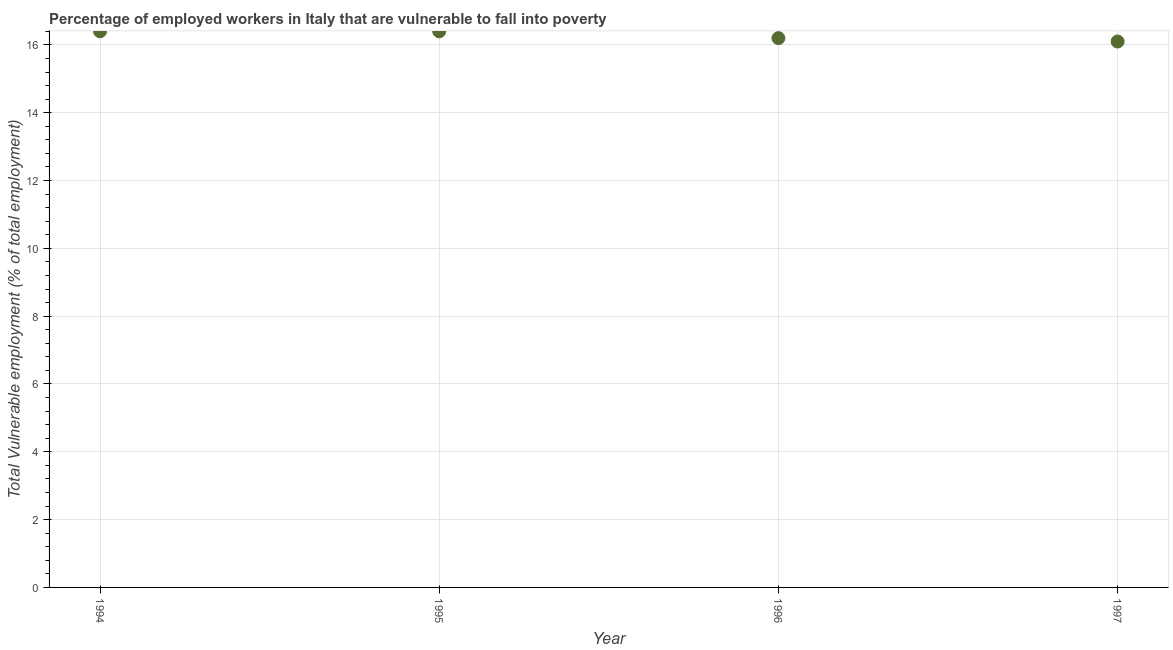What is the total vulnerable employment in 1995?
Your answer should be compact. 16.4. Across all years, what is the maximum total vulnerable employment?
Provide a succinct answer. 16.4. Across all years, what is the minimum total vulnerable employment?
Provide a succinct answer. 16.1. In which year was the total vulnerable employment maximum?
Provide a succinct answer. 1994. In which year was the total vulnerable employment minimum?
Offer a very short reply. 1997. What is the sum of the total vulnerable employment?
Keep it short and to the point. 65.1. What is the difference between the total vulnerable employment in 1994 and 1996?
Keep it short and to the point. 0.2. What is the average total vulnerable employment per year?
Your response must be concise. 16.28. What is the median total vulnerable employment?
Ensure brevity in your answer.  16.3. Do a majority of the years between 1994 and 1995 (inclusive) have total vulnerable employment greater than 14 %?
Your answer should be compact. Yes. What is the ratio of the total vulnerable employment in 1994 to that in 1996?
Your answer should be very brief. 1.01. Is the difference between the total vulnerable employment in 1995 and 1996 greater than the difference between any two years?
Provide a succinct answer. No. What is the difference between the highest and the second highest total vulnerable employment?
Offer a very short reply. 0. What is the difference between the highest and the lowest total vulnerable employment?
Your answer should be compact. 0.3. In how many years, is the total vulnerable employment greater than the average total vulnerable employment taken over all years?
Keep it short and to the point. 2. Does the total vulnerable employment monotonically increase over the years?
Your response must be concise. No. How many years are there in the graph?
Provide a succinct answer. 4. Are the values on the major ticks of Y-axis written in scientific E-notation?
Give a very brief answer. No. Does the graph contain grids?
Offer a terse response. Yes. What is the title of the graph?
Provide a succinct answer. Percentage of employed workers in Italy that are vulnerable to fall into poverty. What is the label or title of the X-axis?
Provide a succinct answer. Year. What is the label or title of the Y-axis?
Make the answer very short. Total Vulnerable employment (% of total employment). What is the Total Vulnerable employment (% of total employment) in 1994?
Your answer should be very brief. 16.4. What is the Total Vulnerable employment (% of total employment) in 1995?
Your answer should be compact. 16.4. What is the Total Vulnerable employment (% of total employment) in 1996?
Your response must be concise. 16.2. What is the Total Vulnerable employment (% of total employment) in 1997?
Your answer should be compact. 16.1. What is the difference between the Total Vulnerable employment (% of total employment) in 1994 and 1995?
Give a very brief answer. 0. What is the difference between the Total Vulnerable employment (% of total employment) in 1995 and 1997?
Your answer should be compact. 0.3. What is the difference between the Total Vulnerable employment (% of total employment) in 1996 and 1997?
Provide a short and direct response. 0.1. What is the ratio of the Total Vulnerable employment (% of total employment) in 1994 to that in 1997?
Offer a terse response. 1.02. What is the ratio of the Total Vulnerable employment (% of total employment) in 1996 to that in 1997?
Provide a succinct answer. 1.01. 